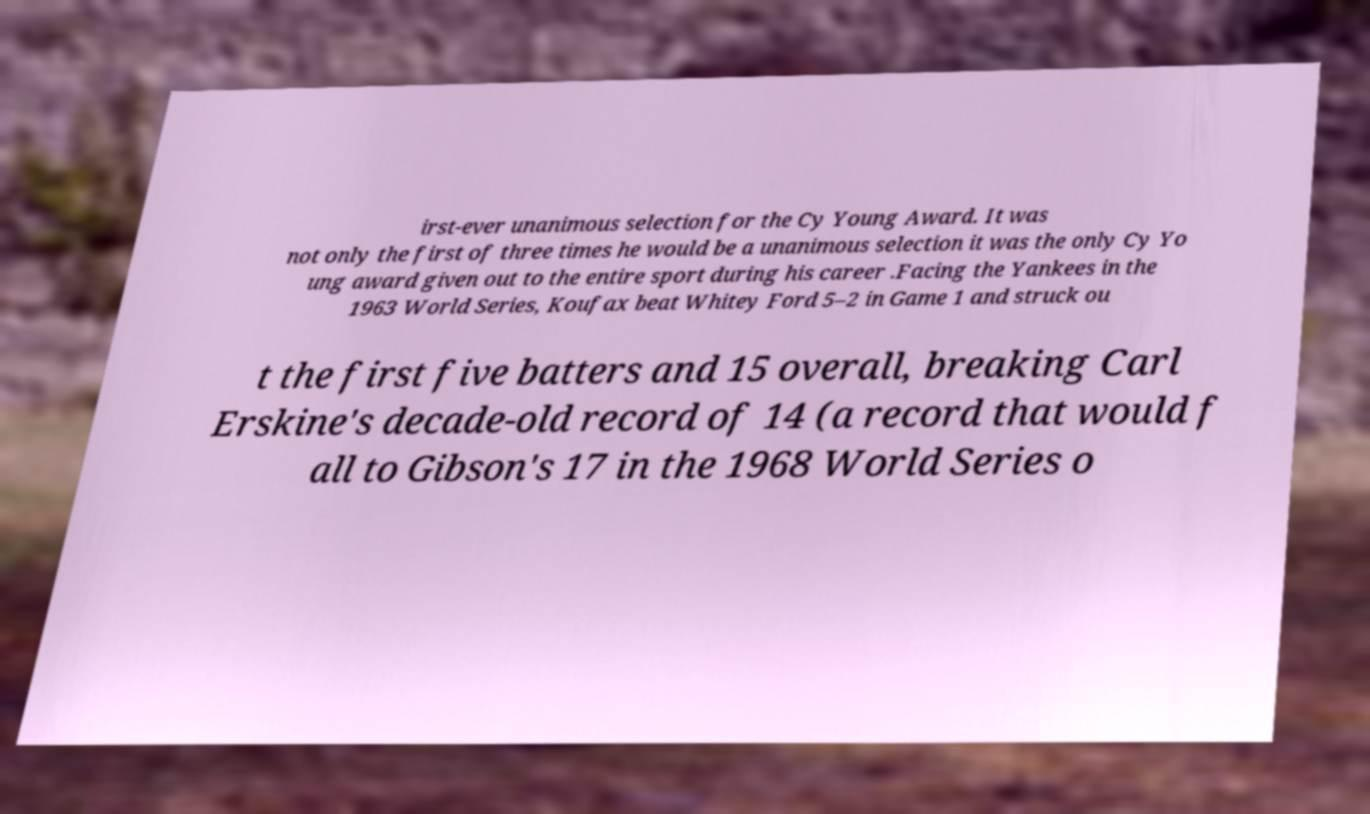Could you extract and type out the text from this image? irst-ever unanimous selection for the Cy Young Award. It was not only the first of three times he would be a unanimous selection it was the only Cy Yo ung award given out to the entire sport during his career .Facing the Yankees in the 1963 World Series, Koufax beat Whitey Ford 5–2 in Game 1 and struck ou t the first five batters and 15 overall, breaking Carl Erskine's decade-old record of 14 (a record that would f all to Gibson's 17 in the 1968 World Series o 